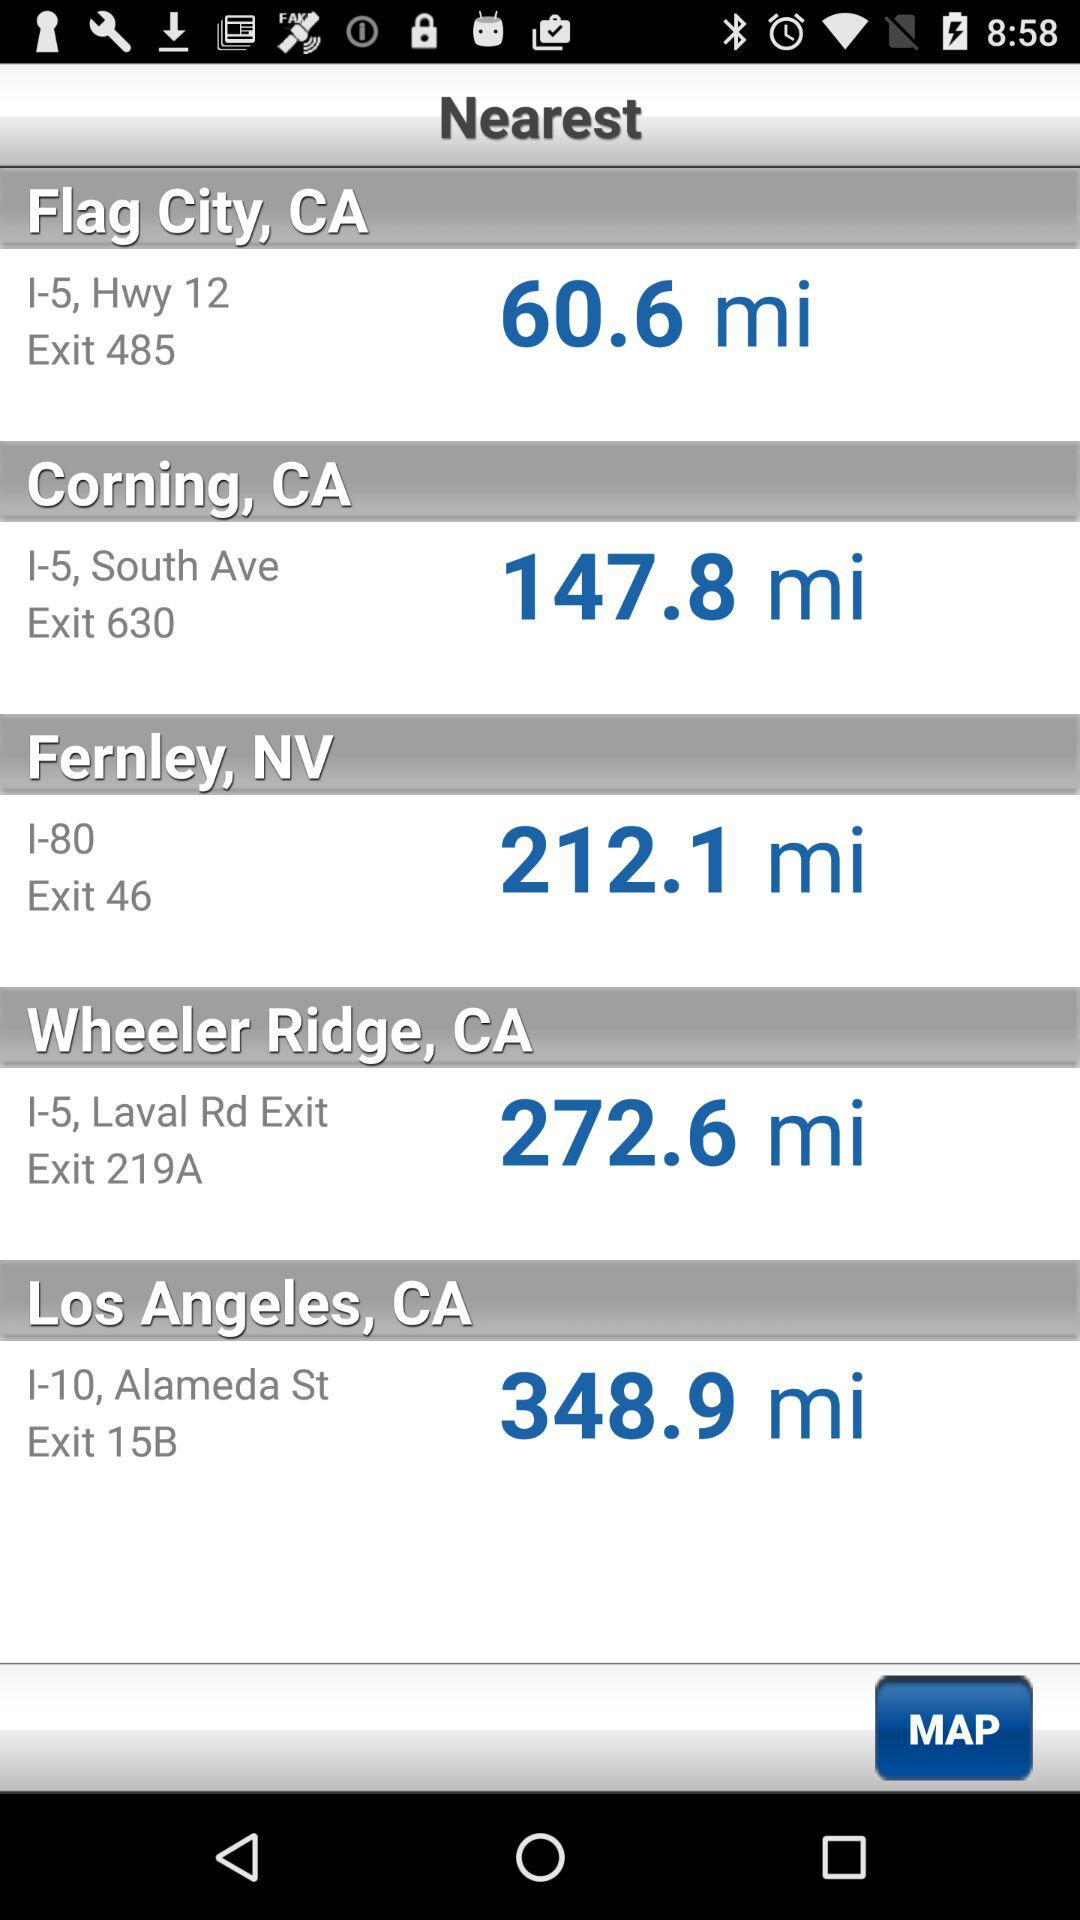What is the exit for Wheeler Ridge City? The exit for Wheeler Ridge City is 219A. 